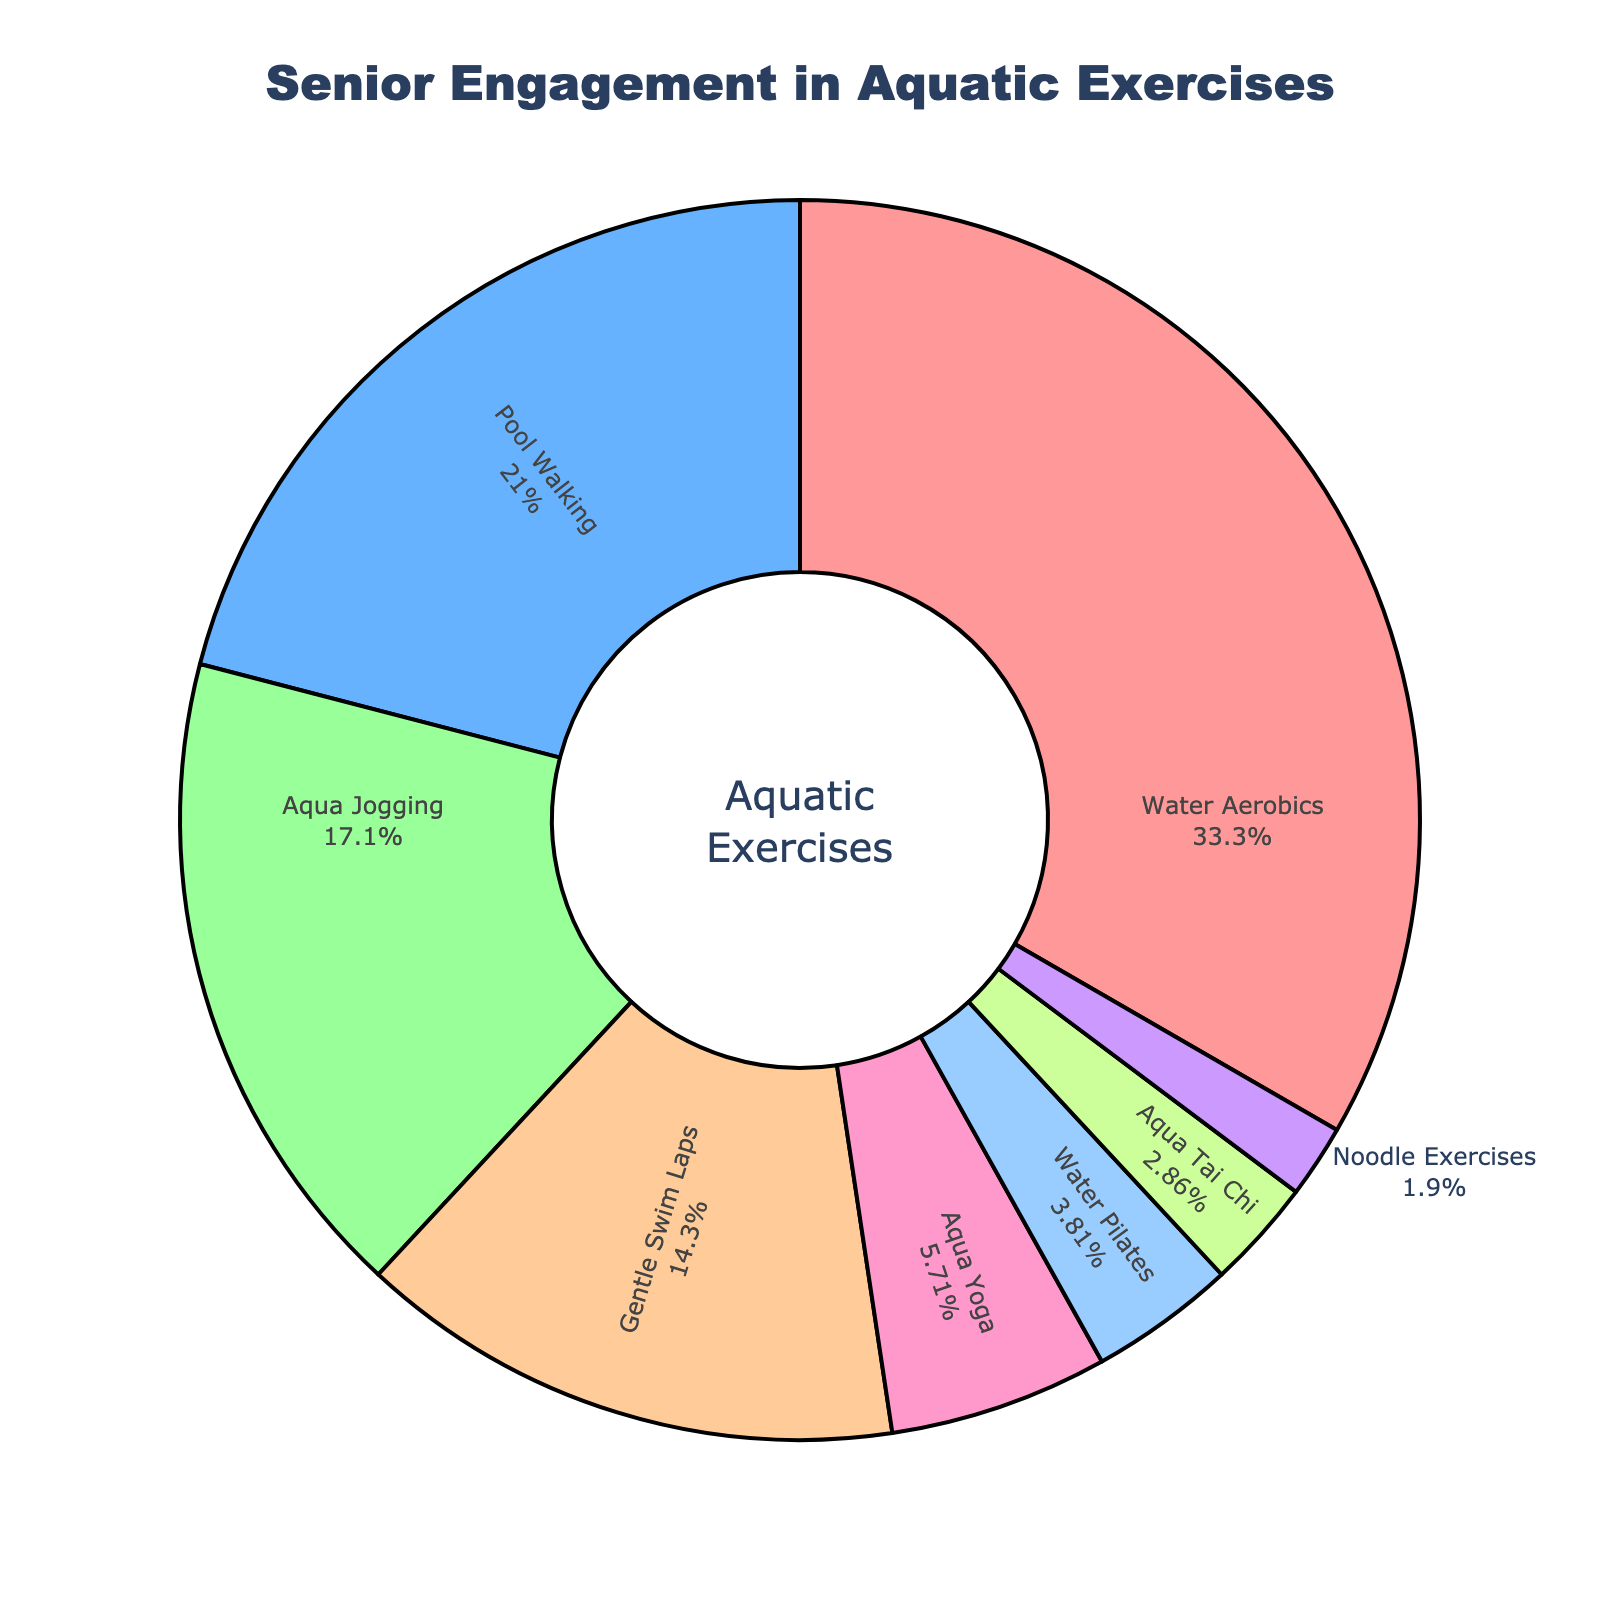Which type of aquatic exercise has the highest engagement among seniors? The pie chart shows the percentage of seniors engaging in different types of aquatic exercises. By looking at the slices, "Water Aerobics" has the largest slice, indicating it has the highest engagement.
Answer: Water Aerobics What is the combined percentage of seniors engaged in Pool Walking and Aqua Jogging? To find the combined percentage, add the percentage of seniors engaging in Pool Walking and Aqua Jogging. Pool Walking is 22% and Aqua Jogging is 18%. The sum is 22% + 18% = 40%.
Answer: 40% How many more seniors engage in Gentle Swim Laps compared to Noodle Exercises? To find the difference, subtract the percentage of seniors engaging in Noodle Exercises from those engaging in Gentle Swim Laps. Gentle Swim Laps is 15% and Noodle Exercises is 2%. The difference is 15% - 2% = 13%.
Answer: 13% Which aquatic exercise has the smallest engagement among seniors? The pie chart shows various slices representing different aquatic exercises. The smallest slice, representing the least engagement, corresponds to "Noodle Exercises" at 2%.
Answer: Noodle Exercises What is the difference in engagement percentage between Aqua Yoga and Water Pilates? To determine the difference, subtract the percentage of seniors engaging in Water Pilates from those in Aqua Yoga. Aqua Yoga is 6% and Water Pilates is 4%. The difference is 6% - 4% = 2%.
Answer: 2% Are there more seniors engaged in Pool Walking or Aqua Tai Chi? The pie chart shows the engagement percentages for different aquatic exercises. Comparing Pool Walking at 22% with Aqua Tai Chi at 3%, Pool Walking has a higher percentage.
Answer: Pool Walking What percentage of seniors engage in exercises other than Water Aerobics? To find the percentage of seniors engaged in exercises other than Water Aerobics, subtract the percentage of Water Aerobics from 100%. Water Aerobics is 35%. So, 100% - 35% = 65%.
Answer: 65% How does the engagement in Aqua Yoga compare to any two exercises combined, such as Aqua Tai Chi and Noodle Exercises? First, add the percentages of Aqua Tai Chi and Noodle Exercises: 3% + 2% = 5%. Now compare with Aqua Yoga at 6%. Since Aqua Yoga (6%) is greater than Aqua Tai Chi + Noodle Exercises (5%), Aqua Yoga has higher engagement.
Answer: Aqua Yoga has higher engagement Which two exercise categories have a total engagement closest to 40%? To solve this, consider possible combinations: Pool Walking (22%) + Aqua Jogging (18%) = 40%, Gentle Swim Laps (15%) + Aqua Yoga (6%) + Water Pilates (4%) = 25%. The closest combination is Pool Walking and Aqua Jogging, which sums exactly to 40%.
Answer: Pool Walking and Aqua Jogging 